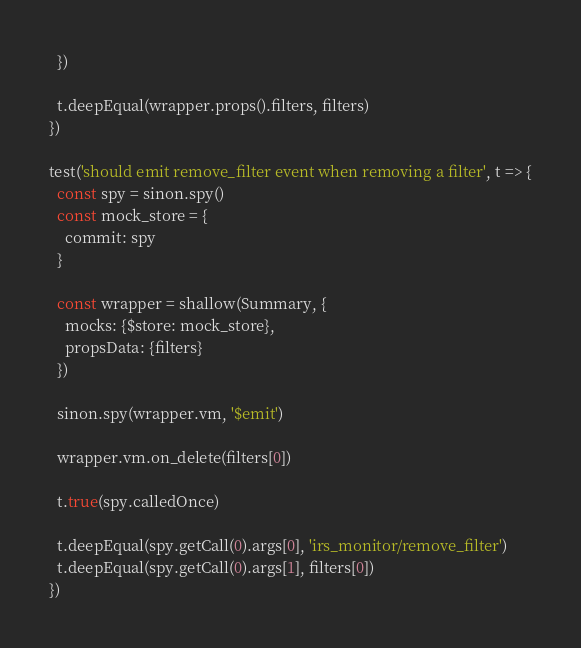Convert code to text. <code><loc_0><loc_0><loc_500><loc_500><_JavaScript_>  })

  t.deepEqual(wrapper.props().filters, filters)
})

test('should emit remove_filter event when removing a filter', t => {
  const spy = sinon.spy()
  const mock_store = {
    commit: spy
  }

  const wrapper = shallow(Summary, {
    mocks: {$store: mock_store},
    propsData: {filters}
  })

  sinon.spy(wrapper.vm, '$emit')

  wrapper.vm.on_delete(filters[0])

  t.true(spy.calledOnce)

  t.deepEqual(spy.getCall(0).args[0], 'irs_monitor/remove_filter')
  t.deepEqual(spy.getCall(0).args[1], filters[0])
})</code> 